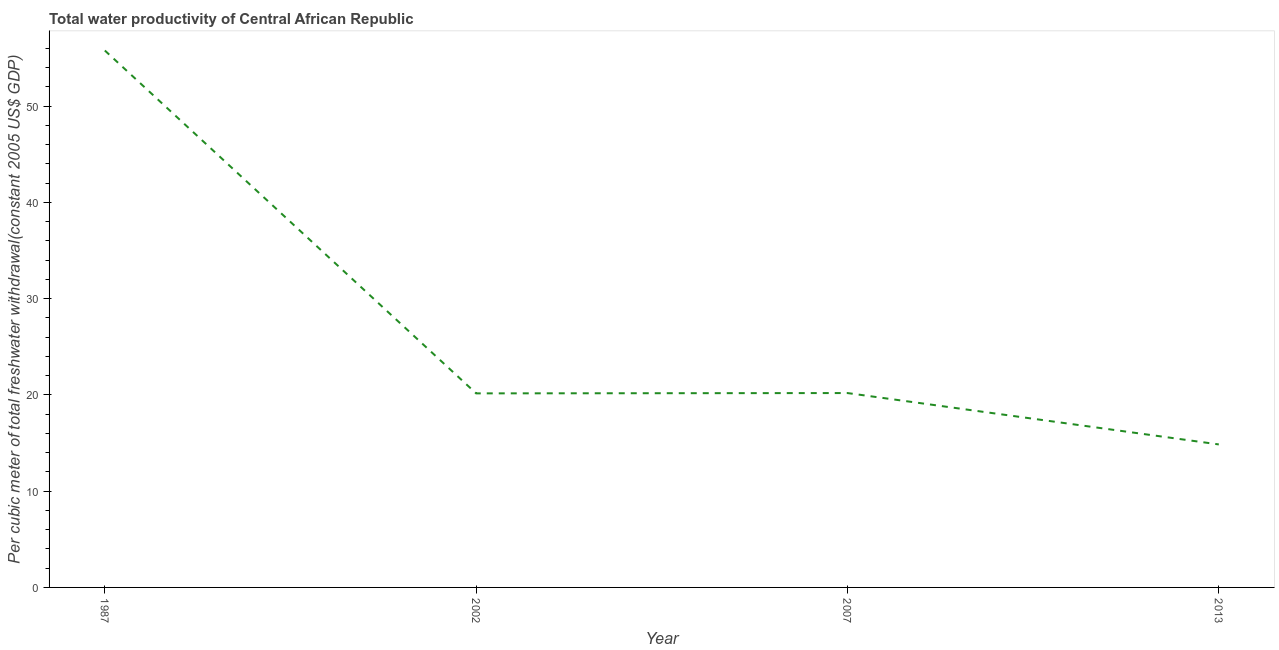What is the total water productivity in 1987?
Offer a very short reply. 55.77. Across all years, what is the maximum total water productivity?
Provide a short and direct response. 55.77. Across all years, what is the minimum total water productivity?
Ensure brevity in your answer.  14.86. What is the sum of the total water productivity?
Offer a terse response. 110.98. What is the difference between the total water productivity in 1987 and 2007?
Offer a terse response. 35.58. What is the average total water productivity per year?
Ensure brevity in your answer.  27.75. What is the median total water productivity?
Provide a succinct answer. 20.18. Do a majority of the years between 2013 and 1987 (inclusive) have total water productivity greater than 48 US$?
Give a very brief answer. Yes. What is the ratio of the total water productivity in 2002 to that in 2007?
Your answer should be very brief. 1. Is the difference between the total water productivity in 1987 and 2002 greater than the difference between any two years?
Your answer should be very brief. No. What is the difference between the highest and the second highest total water productivity?
Your response must be concise. 35.58. Is the sum of the total water productivity in 2002 and 2013 greater than the maximum total water productivity across all years?
Your answer should be very brief. No. What is the difference between the highest and the lowest total water productivity?
Give a very brief answer. 40.92. In how many years, is the total water productivity greater than the average total water productivity taken over all years?
Keep it short and to the point. 1. Does the total water productivity monotonically increase over the years?
Keep it short and to the point. No. How many years are there in the graph?
Ensure brevity in your answer.  4. Are the values on the major ticks of Y-axis written in scientific E-notation?
Offer a very short reply. No. What is the title of the graph?
Offer a terse response. Total water productivity of Central African Republic. What is the label or title of the Y-axis?
Give a very brief answer. Per cubic meter of total freshwater withdrawal(constant 2005 US$ GDP). What is the Per cubic meter of total freshwater withdrawal(constant 2005 US$ GDP) in 1987?
Make the answer very short. 55.77. What is the Per cubic meter of total freshwater withdrawal(constant 2005 US$ GDP) of 2002?
Your answer should be compact. 20.16. What is the Per cubic meter of total freshwater withdrawal(constant 2005 US$ GDP) of 2007?
Provide a succinct answer. 20.19. What is the Per cubic meter of total freshwater withdrawal(constant 2005 US$ GDP) of 2013?
Your response must be concise. 14.86. What is the difference between the Per cubic meter of total freshwater withdrawal(constant 2005 US$ GDP) in 1987 and 2002?
Give a very brief answer. 35.62. What is the difference between the Per cubic meter of total freshwater withdrawal(constant 2005 US$ GDP) in 1987 and 2007?
Your answer should be compact. 35.58. What is the difference between the Per cubic meter of total freshwater withdrawal(constant 2005 US$ GDP) in 1987 and 2013?
Keep it short and to the point. 40.92. What is the difference between the Per cubic meter of total freshwater withdrawal(constant 2005 US$ GDP) in 2002 and 2007?
Keep it short and to the point. -0.03. What is the difference between the Per cubic meter of total freshwater withdrawal(constant 2005 US$ GDP) in 2002 and 2013?
Give a very brief answer. 5.3. What is the difference between the Per cubic meter of total freshwater withdrawal(constant 2005 US$ GDP) in 2007 and 2013?
Keep it short and to the point. 5.34. What is the ratio of the Per cubic meter of total freshwater withdrawal(constant 2005 US$ GDP) in 1987 to that in 2002?
Make the answer very short. 2.77. What is the ratio of the Per cubic meter of total freshwater withdrawal(constant 2005 US$ GDP) in 1987 to that in 2007?
Keep it short and to the point. 2.76. What is the ratio of the Per cubic meter of total freshwater withdrawal(constant 2005 US$ GDP) in 1987 to that in 2013?
Provide a short and direct response. 3.75. What is the ratio of the Per cubic meter of total freshwater withdrawal(constant 2005 US$ GDP) in 2002 to that in 2007?
Keep it short and to the point. 1. What is the ratio of the Per cubic meter of total freshwater withdrawal(constant 2005 US$ GDP) in 2002 to that in 2013?
Your response must be concise. 1.36. What is the ratio of the Per cubic meter of total freshwater withdrawal(constant 2005 US$ GDP) in 2007 to that in 2013?
Provide a short and direct response. 1.36. 